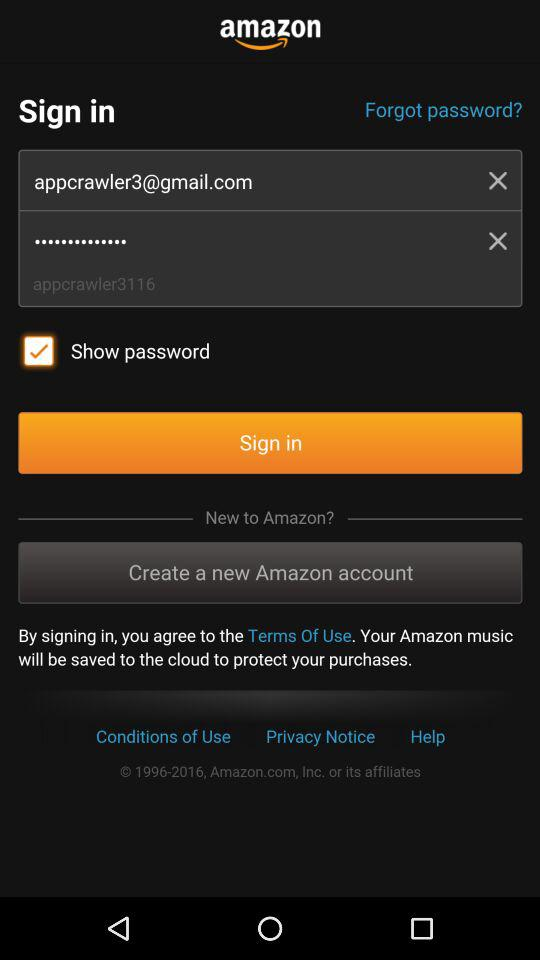What is the email address? The email address is appcrawler3@gmail.com. 